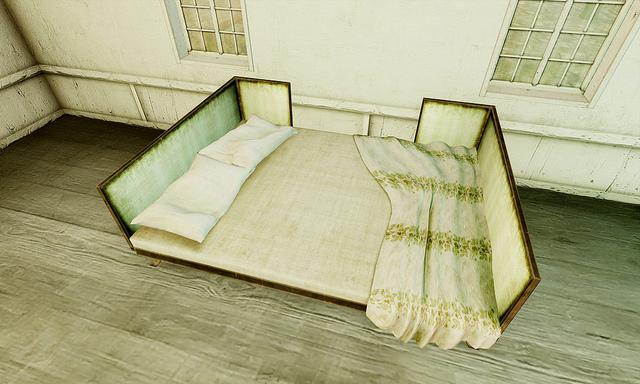How many windows are visible?
Give a very brief answer. 2. How many pillows are on the bed?
Concise answer only. 2. What color is the headboard?
Keep it brief. White. 